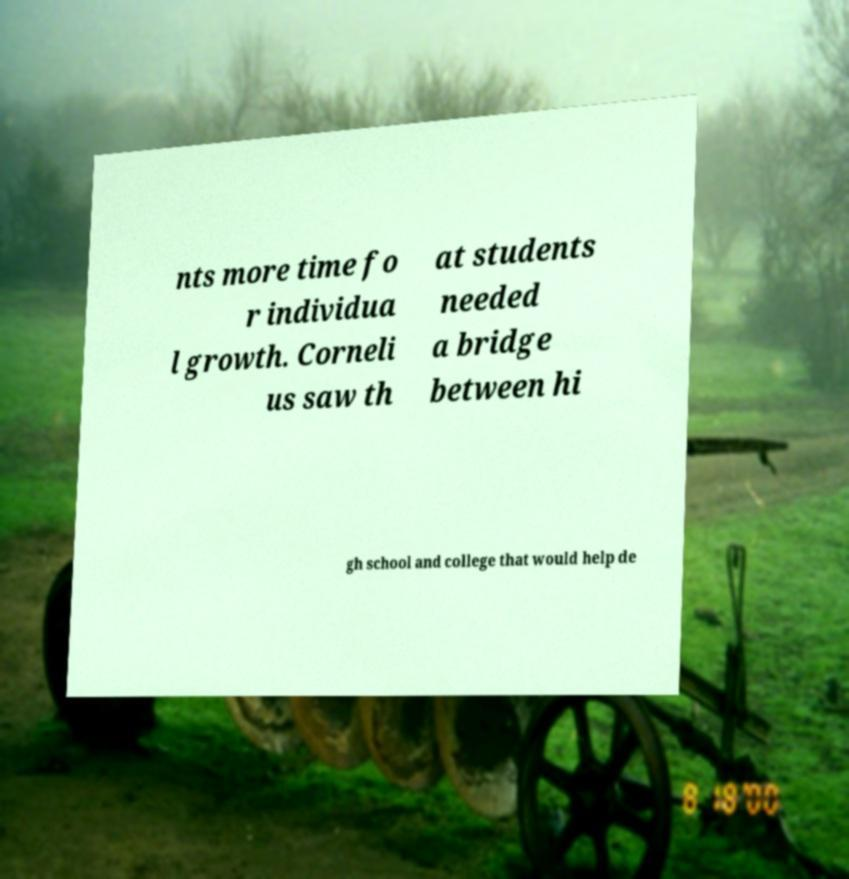Could you assist in decoding the text presented in this image and type it out clearly? nts more time fo r individua l growth. Corneli us saw th at students needed a bridge between hi gh school and college that would help de 